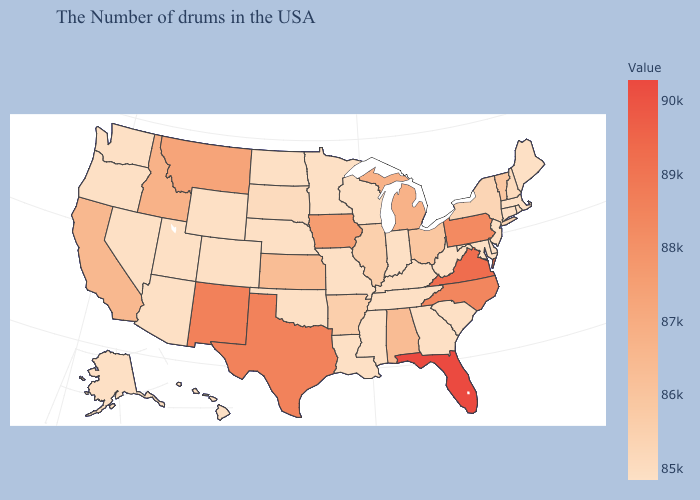Which states hav the highest value in the West?
Answer briefly. New Mexico. Does Nevada have a lower value than Kansas?
Write a very short answer. Yes. Among the states that border New York , does Pennsylvania have the lowest value?
Be succinct. No. Which states have the lowest value in the USA?
Answer briefly. Maine, Massachusetts, Rhode Island, Connecticut, New Jersey, Delaware, Maryland, South Carolina, West Virginia, Georgia, Indiana, Tennessee, Wisconsin, Mississippi, Louisiana, Missouri, Minnesota, Nebraska, Oklahoma, North Dakota, Wyoming, Colorado, Utah, Arizona, Nevada, Washington, Oregon, Alaska, Hawaii. Among the states that border Colorado , does New Mexico have the lowest value?
Quick response, please. No. Does Florida have the highest value in the USA?
Give a very brief answer. Yes. Does the map have missing data?
Write a very short answer. No. 